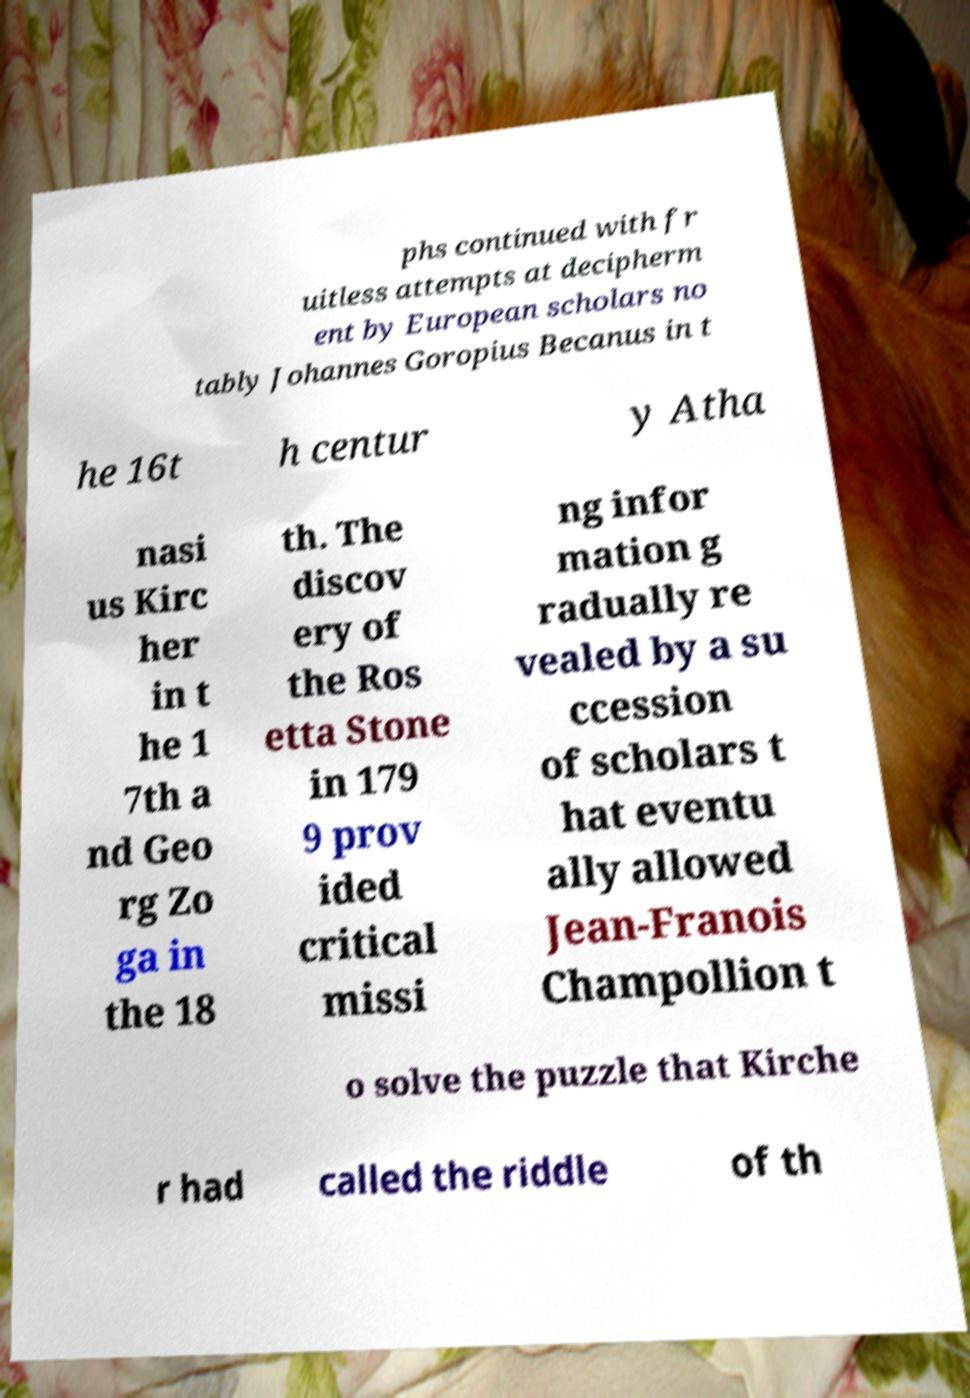What messages or text are displayed in this image? I need them in a readable, typed format. phs continued with fr uitless attempts at decipherm ent by European scholars no tably Johannes Goropius Becanus in t he 16t h centur y Atha nasi us Kirc her in t he 1 7th a nd Geo rg Zo ga in the 18 th. The discov ery of the Ros etta Stone in 179 9 prov ided critical missi ng infor mation g radually re vealed by a su ccession of scholars t hat eventu ally allowed Jean-Franois Champollion t o solve the puzzle that Kirche r had called the riddle of th 